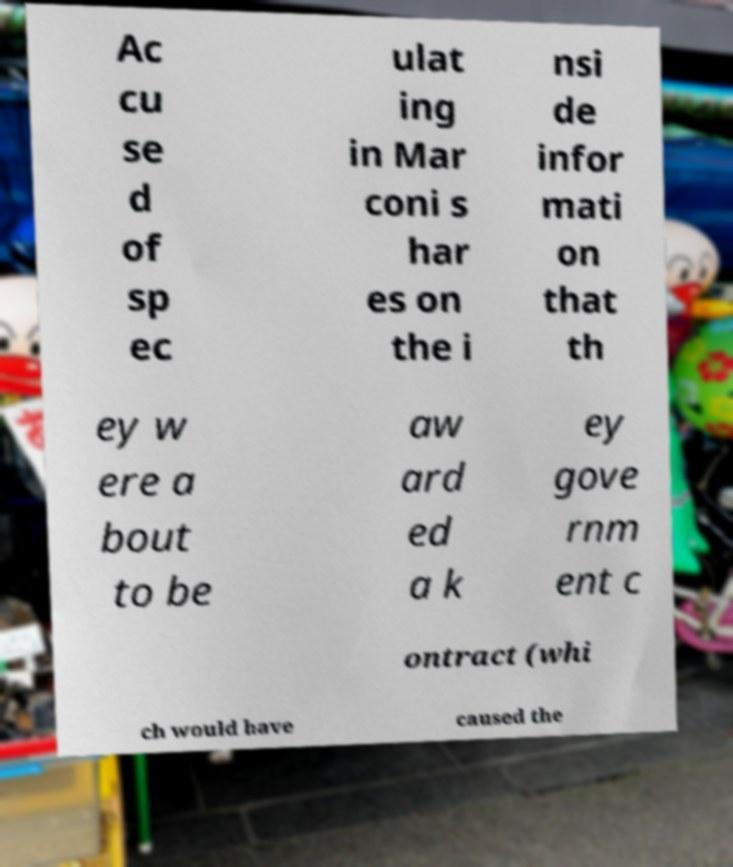Please identify and transcribe the text found in this image. Ac cu se d of sp ec ulat ing in Mar coni s har es on the i nsi de infor mati on that th ey w ere a bout to be aw ard ed a k ey gove rnm ent c ontract (whi ch would have caused the 